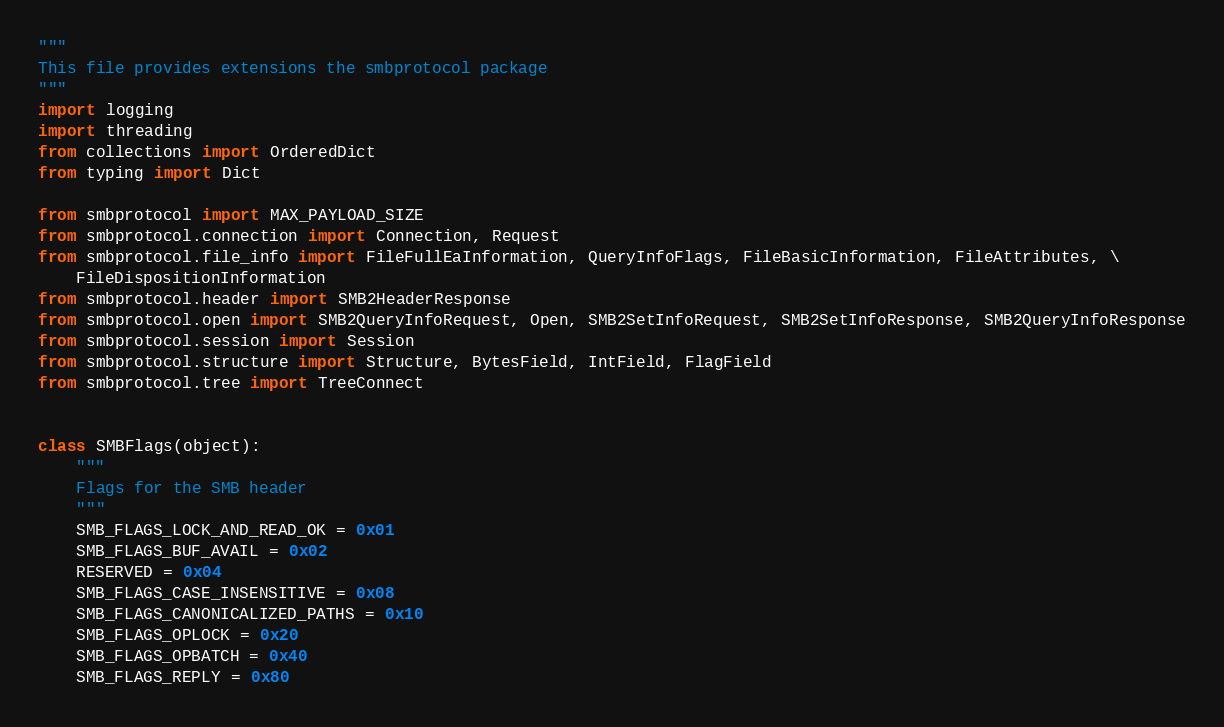<code> <loc_0><loc_0><loc_500><loc_500><_Python_>"""
This file provides extensions the smbprotocol package
"""
import logging
import threading
from collections import OrderedDict
from typing import Dict

from smbprotocol import MAX_PAYLOAD_SIZE
from smbprotocol.connection import Connection, Request
from smbprotocol.file_info import FileFullEaInformation, QueryInfoFlags, FileBasicInformation, FileAttributes, \
    FileDispositionInformation
from smbprotocol.header import SMB2HeaderResponse
from smbprotocol.open import SMB2QueryInfoRequest, Open, SMB2SetInfoRequest, SMB2SetInfoResponse, SMB2QueryInfoResponse
from smbprotocol.session import Session
from smbprotocol.structure import Structure, BytesField, IntField, FlagField
from smbprotocol.tree import TreeConnect


class SMBFlags(object):
    """
    Flags for the SMB header
    """
    SMB_FLAGS_LOCK_AND_READ_OK = 0x01
    SMB_FLAGS_BUF_AVAIL = 0x02
    RESERVED = 0x04
    SMB_FLAGS_CASE_INSENSITIVE = 0x08
    SMB_FLAGS_CANONICALIZED_PATHS = 0x10
    SMB_FLAGS_OPLOCK = 0x20
    SMB_FLAGS_OPBATCH = 0x40
    SMB_FLAGS_REPLY = 0x80

</code> 